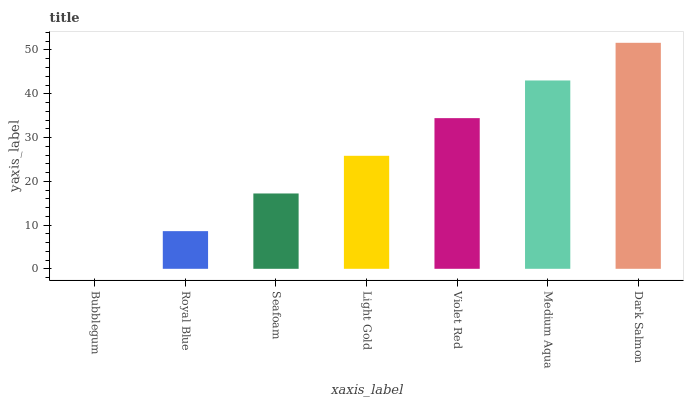Is Bubblegum the minimum?
Answer yes or no. Yes. Is Dark Salmon the maximum?
Answer yes or no. Yes. Is Royal Blue the minimum?
Answer yes or no. No. Is Royal Blue the maximum?
Answer yes or no. No. Is Royal Blue greater than Bubblegum?
Answer yes or no. Yes. Is Bubblegum less than Royal Blue?
Answer yes or no. Yes. Is Bubblegum greater than Royal Blue?
Answer yes or no. No. Is Royal Blue less than Bubblegum?
Answer yes or no. No. Is Light Gold the high median?
Answer yes or no. Yes. Is Light Gold the low median?
Answer yes or no. Yes. Is Medium Aqua the high median?
Answer yes or no. No. Is Dark Salmon the low median?
Answer yes or no. No. 